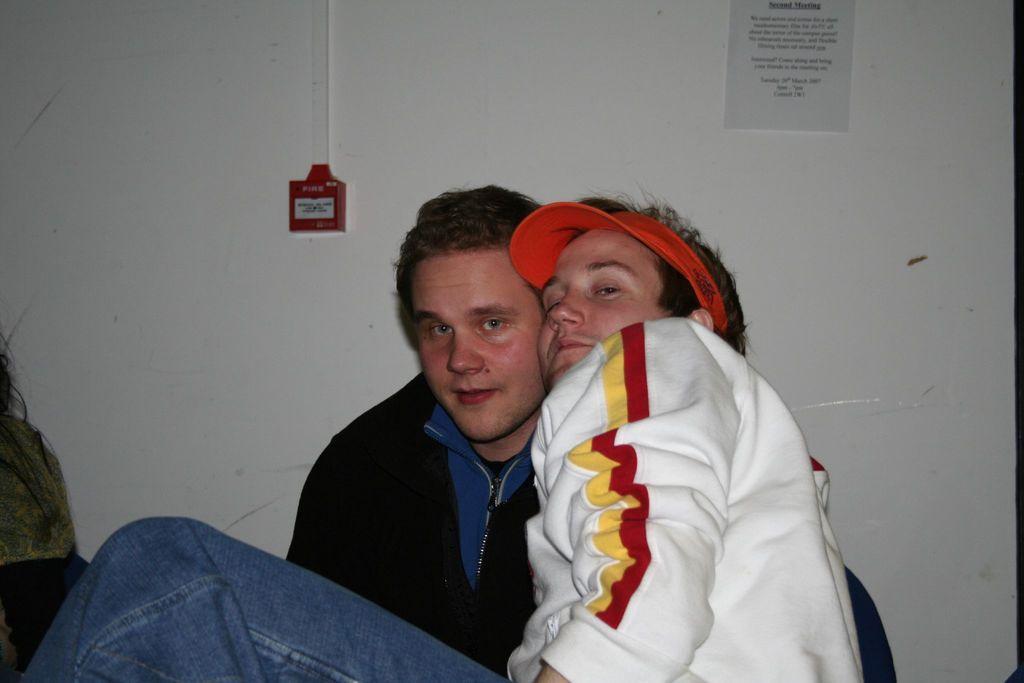Can you describe this image briefly? In the middle a man is there, he wore white color sweater beside him there is another man, he wore black color sweater. Behind them it's a wall. 